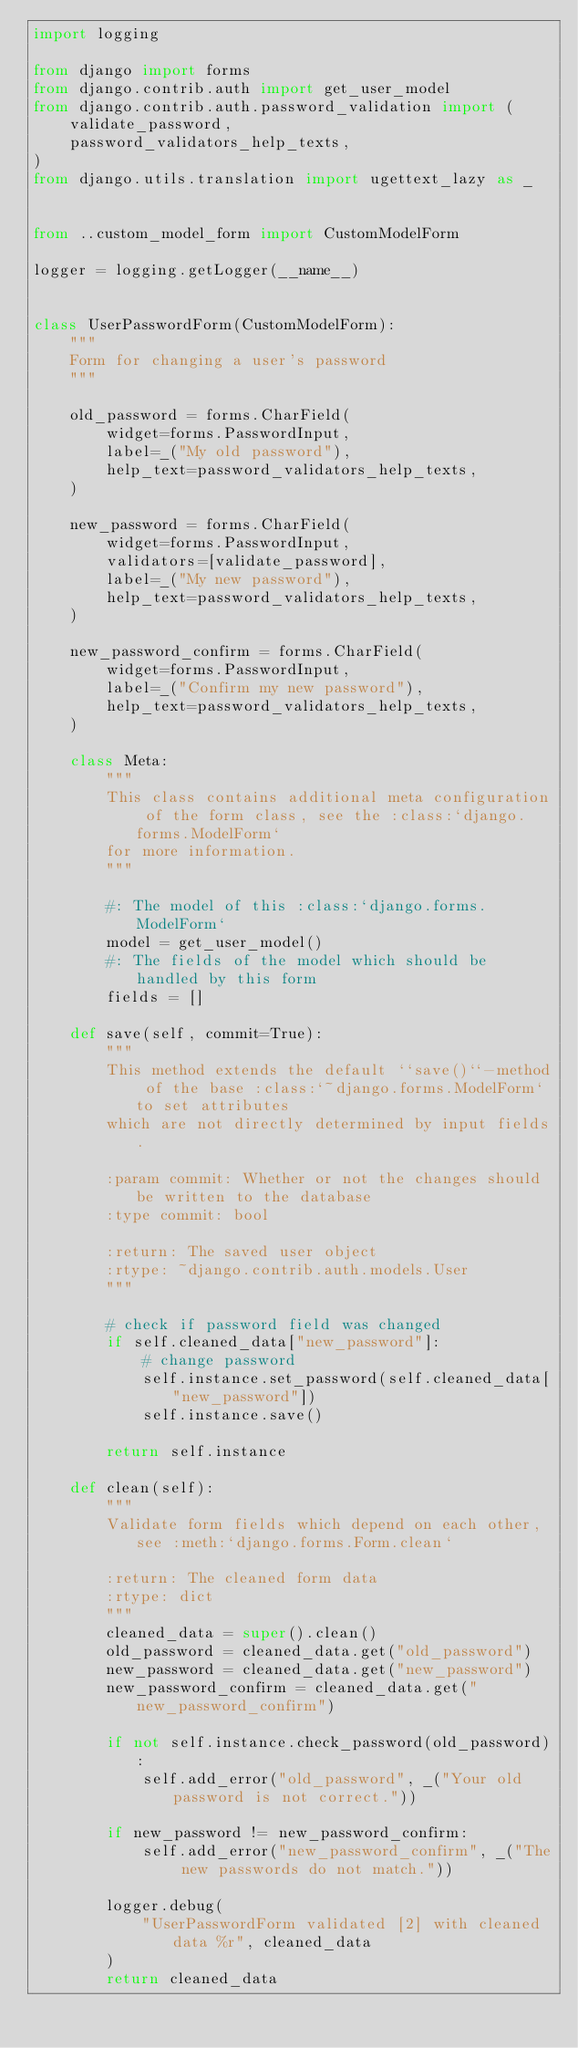Convert code to text. <code><loc_0><loc_0><loc_500><loc_500><_Python_>import logging

from django import forms
from django.contrib.auth import get_user_model
from django.contrib.auth.password_validation import (
    validate_password,
    password_validators_help_texts,
)
from django.utils.translation import ugettext_lazy as _


from ..custom_model_form import CustomModelForm

logger = logging.getLogger(__name__)


class UserPasswordForm(CustomModelForm):
    """
    Form for changing a user's password
    """

    old_password = forms.CharField(
        widget=forms.PasswordInput,
        label=_("My old password"),
        help_text=password_validators_help_texts,
    )

    new_password = forms.CharField(
        widget=forms.PasswordInput,
        validators=[validate_password],
        label=_("My new password"),
        help_text=password_validators_help_texts,
    )

    new_password_confirm = forms.CharField(
        widget=forms.PasswordInput,
        label=_("Confirm my new password"),
        help_text=password_validators_help_texts,
    )

    class Meta:
        """
        This class contains additional meta configuration of the form class, see the :class:`django.forms.ModelForm`
        for more information.
        """

        #: The model of this :class:`django.forms.ModelForm`
        model = get_user_model()
        #: The fields of the model which should be handled by this form
        fields = []

    def save(self, commit=True):
        """
        This method extends the default ``save()``-method of the base :class:`~django.forms.ModelForm` to set attributes
        which are not directly determined by input fields.

        :param commit: Whether or not the changes should be written to the database
        :type commit: bool

        :return: The saved user object
        :rtype: ~django.contrib.auth.models.User
        """

        # check if password field was changed
        if self.cleaned_data["new_password"]:
            # change password
            self.instance.set_password(self.cleaned_data["new_password"])
            self.instance.save()

        return self.instance

    def clean(self):
        """
        Validate form fields which depend on each other, see :meth:`django.forms.Form.clean`

        :return: The cleaned form data
        :rtype: dict
        """
        cleaned_data = super().clean()
        old_password = cleaned_data.get("old_password")
        new_password = cleaned_data.get("new_password")
        new_password_confirm = cleaned_data.get("new_password_confirm")

        if not self.instance.check_password(old_password):
            self.add_error("old_password", _("Your old password is not correct."))

        if new_password != new_password_confirm:
            self.add_error("new_password_confirm", _("The new passwords do not match."))

        logger.debug(
            "UserPasswordForm validated [2] with cleaned data %r", cleaned_data
        )
        return cleaned_data
</code> 